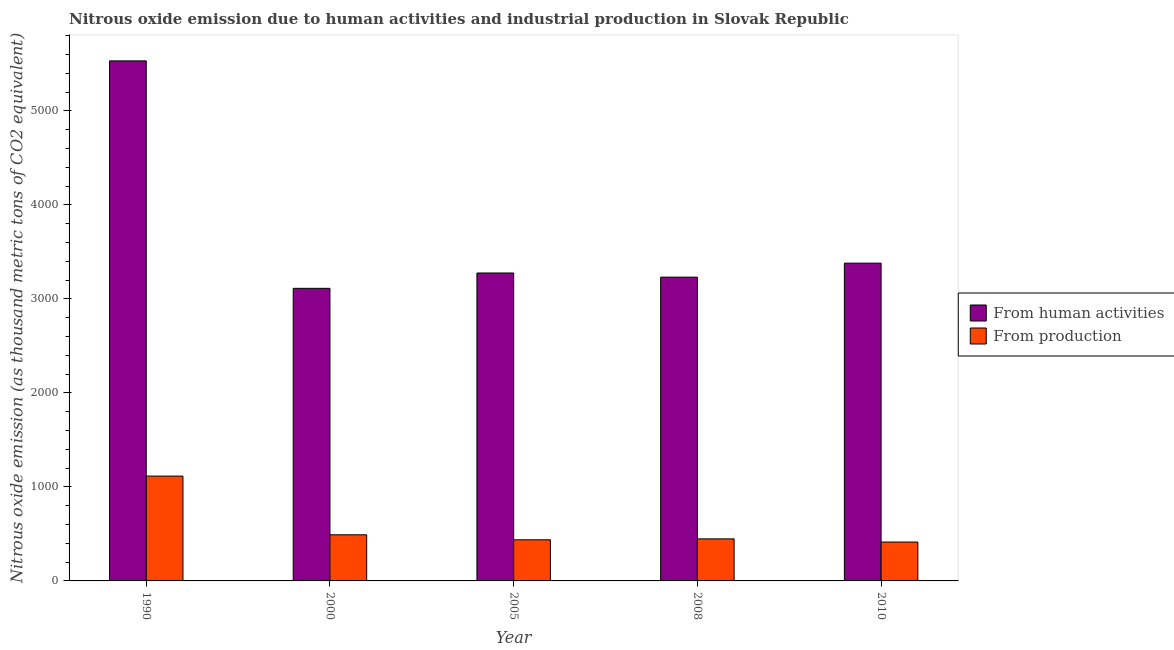How many groups of bars are there?
Your answer should be very brief. 5. Are the number of bars on each tick of the X-axis equal?
Your answer should be compact. Yes. How many bars are there on the 5th tick from the right?
Offer a very short reply. 2. What is the label of the 4th group of bars from the left?
Your response must be concise. 2008. What is the amount of emissions generated from industries in 2005?
Your answer should be very brief. 437.5. Across all years, what is the maximum amount of emissions generated from industries?
Your response must be concise. 1115.2. Across all years, what is the minimum amount of emissions generated from industries?
Keep it short and to the point. 413.6. In which year was the amount of emissions from human activities maximum?
Offer a terse response. 1990. In which year was the amount of emissions generated from industries minimum?
Your answer should be very brief. 2010. What is the total amount of emissions from human activities in the graph?
Offer a terse response. 1.85e+04. What is the difference between the amount of emissions generated from industries in 1990 and that in 2010?
Provide a succinct answer. 701.6. What is the difference between the amount of emissions from human activities in 1990 and the amount of emissions generated from industries in 2005?
Offer a very short reply. 2256.3. What is the average amount of emissions from human activities per year?
Provide a short and direct response. 3706.28. In the year 2008, what is the difference between the amount of emissions generated from industries and amount of emissions from human activities?
Offer a terse response. 0. In how many years, is the amount of emissions generated from industries greater than 2800 thousand metric tons?
Offer a terse response. 0. What is the ratio of the amount of emissions from human activities in 2000 to that in 2005?
Provide a succinct answer. 0.95. What is the difference between the highest and the second highest amount of emissions from human activities?
Keep it short and to the point. 2151.7. What is the difference between the highest and the lowest amount of emissions from human activities?
Your response must be concise. 2419.6. Is the sum of the amount of emissions from human activities in 1990 and 2010 greater than the maximum amount of emissions generated from industries across all years?
Give a very brief answer. Yes. What does the 2nd bar from the left in 2000 represents?
Provide a succinct answer. From production. What does the 2nd bar from the right in 2008 represents?
Offer a terse response. From human activities. How many years are there in the graph?
Your response must be concise. 5. What is the difference between two consecutive major ticks on the Y-axis?
Give a very brief answer. 1000. Does the graph contain any zero values?
Your answer should be very brief. No. Does the graph contain grids?
Offer a very short reply. No. What is the title of the graph?
Offer a very short reply. Nitrous oxide emission due to human activities and industrial production in Slovak Republic. What is the label or title of the X-axis?
Provide a succinct answer. Year. What is the label or title of the Y-axis?
Your response must be concise. Nitrous oxide emission (as thousand metric tons of CO2 equivalent). What is the Nitrous oxide emission (as thousand metric tons of CO2 equivalent) in From human activities in 1990?
Give a very brief answer. 5531.9. What is the Nitrous oxide emission (as thousand metric tons of CO2 equivalent) in From production in 1990?
Provide a succinct answer. 1115.2. What is the Nitrous oxide emission (as thousand metric tons of CO2 equivalent) in From human activities in 2000?
Give a very brief answer. 3112.3. What is the Nitrous oxide emission (as thousand metric tons of CO2 equivalent) in From production in 2000?
Your answer should be very brief. 490.8. What is the Nitrous oxide emission (as thousand metric tons of CO2 equivalent) in From human activities in 2005?
Offer a terse response. 3275.6. What is the Nitrous oxide emission (as thousand metric tons of CO2 equivalent) in From production in 2005?
Keep it short and to the point. 437.5. What is the Nitrous oxide emission (as thousand metric tons of CO2 equivalent) of From human activities in 2008?
Offer a terse response. 3231.4. What is the Nitrous oxide emission (as thousand metric tons of CO2 equivalent) in From production in 2008?
Your answer should be very brief. 447.3. What is the Nitrous oxide emission (as thousand metric tons of CO2 equivalent) of From human activities in 2010?
Your answer should be compact. 3380.2. What is the Nitrous oxide emission (as thousand metric tons of CO2 equivalent) of From production in 2010?
Ensure brevity in your answer.  413.6. Across all years, what is the maximum Nitrous oxide emission (as thousand metric tons of CO2 equivalent) of From human activities?
Provide a short and direct response. 5531.9. Across all years, what is the maximum Nitrous oxide emission (as thousand metric tons of CO2 equivalent) in From production?
Provide a short and direct response. 1115.2. Across all years, what is the minimum Nitrous oxide emission (as thousand metric tons of CO2 equivalent) of From human activities?
Provide a short and direct response. 3112.3. Across all years, what is the minimum Nitrous oxide emission (as thousand metric tons of CO2 equivalent) of From production?
Ensure brevity in your answer.  413.6. What is the total Nitrous oxide emission (as thousand metric tons of CO2 equivalent) in From human activities in the graph?
Provide a succinct answer. 1.85e+04. What is the total Nitrous oxide emission (as thousand metric tons of CO2 equivalent) in From production in the graph?
Your response must be concise. 2904.4. What is the difference between the Nitrous oxide emission (as thousand metric tons of CO2 equivalent) of From human activities in 1990 and that in 2000?
Keep it short and to the point. 2419.6. What is the difference between the Nitrous oxide emission (as thousand metric tons of CO2 equivalent) in From production in 1990 and that in 2000?
Give a very brief answer. 624.4. What is the difference between the Nitrous oxide emission (as thousand metric tons of CO2 equivalent) of From human activities in 1990 and that in 2005?
Provide a succinct answer. 2256.3. What is the difference between the Nitrous oxide emission (as thousand metric tons of CO2 equivalent) in From production in 1990 and that in 2005?
Your answer should be compact. 677.7. What is the difference between the Nitrous oxide emission (as thousand metric tons of CO2 equivalent) in From human activities in 1990 and that in 2008?
Ensure brevity in your answer.  2300.5. What is the difference between the Nitrous oxide emission (as thousand metric tons of CO2 equivalent) of From production in 1990 and that in 2008?
Your answer should be compact. 667.9. What is the difference between the Nitrous oxide emission (as thousand metric tons of CO2 equivalent) in From human activities in 1990 and that in 2010?
Provide a succinct answer. 2151.7. What is the difference between the Nitrous oxide emission (as thousand metric tons of CO2 equivalent) in From production in 1990 and that in 2010?
Your answer should be very brief. 701.6. What is the difference between the Nitrous oxide emission (as thousand metric tons of CO2 equivalent) of From human activities in 2000 and that in 2005?
Provide a short and direct response. -163.3. What is the difference between the Nitrous oxide emission (as thousand metric tons of CO2 equivalent) in From production in 2000 and that in 2005?
Keep it short and to the point. 53.3. What is the difference between the Nitrous oxide emission (as thousand metric tons of CO2 equivalent) in From human activities in 2000 and that in 2008?
Offer a very short reply. -119.1. What is the difference between the Nitrous oxide emission (as thousand metric tons of CO2 equivalent) in From production in 2000 and that in 2008?
Give a very brief answer. 43.5. What is the difference between the Nitrous oxide emission (as thousand metric tons of CO2 equivalent) of From human activities in 2000 and that in 2010?
Provide a succinct answer. -267.9. What is the difference between the Nitrous oxide emission (as thousand metric tons of CO2 equivalent) in From production in 2000 and that in 2010?
Your answer should be compact. 77.2. What is the difference between the Nitrous oxide emission (as thousand metric tons of CO2 equivalent) in From human activities in 2005 and that in 2008?
Offer a very short reply. 44.2. What is the difference between the Nitrous oxide emission (as thousand metric tons of CO2 equivalent) of From human activities in 2005 and that in 2010?
Make the answer very short. -104.6. What is the difference between the Nitrous oxide emission (as thousand metric tons of CO2 equivalent) of From production in 2005 and that in 2010?
Your answer should be compact. 23.9. What is the difference between the Nitrous oxide emission (as thousand metric tons of CO2 equivalent) in From human activities in 2008 and that in 2010?
Provide a short and direct response. -148.8. What is the difference between the Nitrous oxide emission (as thousand metric tons of CO2 equivalent) of From production in 2008 and that in 2010?
Ensure brevity in your answer.  33.7. What is the difference between the Nitrous oxide emission (as thousand metric tons of CO2 equivalent) of From human activities in 1990 and the Nitrous oxide emission (as thousand metric tons of CO2 equivalent) of From production in 2000?
Your response must be concise. 5041.1. What is the difference between the Nitrous oxide emission (as thousand metric tons of CO2 equivalent) of From human activities in 1990 and the Nitrous oxide emission (as thousand metric tons of CO2 equivalent) of From production in 2005?
Your answer should be very brief. 5094.4. What is the difference between the Nitrous oxide emission (as thousand metric tons of CO2 equivalent) in From human activities in 1990 and the Nitrous oxide emission (as thousand metric tons of CO2 equivalent) in From production in 2008?
Your answer should be very brief. 5084.6. What is the difference between the Nitrous oxide emission (as thousand metric tons of CO2 equivalent) of From human activities in 1990 and the Nitrous oxide emission (as thousand metric tons of CO2 equivalent) of From production in 2010?
Provide a short and direct response. 5118.3. What is the difference between the Nitrous oxide emission (as thousand metric tons of CO2 equivalent) of From human activities in 2000 and the Nitrous oxide emission (as thousand metric tons of CO2 equivalent) of From production in 2005?
Offer a terse response. 2674.8. What is the difference between the Nitrous oxide emission (as thousand metric tons of CO2 equivalent) in From human activities in 2000 and the Nitrous oxide emission (as thousand metric tons of CO2 equivalent) in From production in 2008?
Your response must be concise. 2665. What is the difference between the Nitrous oxide emission (as thousand metric tons of CO2 equivalent) of From human activities in 2000 and the Nitrous oxide emission (as thousand metric tons of CO2 equivalent) of From production in 2010?
Give a very brief answer. 2698.7. What is the difference between the Nitrous oxide emission (as thousand metric tons of CO2 equivalent) in From human activities in 2005 and the Nitrous oxide emission (as thousand metric tons of CO2 equivalent) in From production in 2008?
Offer a terse response. 2828.3. What is the difference between the Nitrous oxide emission (as thousand metric tons of CO2 equivalent) of From human activities in 2005 and the Nitrous oxide emission (as thousand metric tons of CO2 equivalent) of From production in 2010?
Your answer should be very brief. 2862. What is the difference between the Nitrous oxide emission (as thousand metric tons of CO2 equivalent) in From human activities in 2008 and the Nitrous oxide emission (as thousand metric tons of CO2 equivalent) in From production in 2010?
Ensure brevity in your answer.  2817.8. What is the average Nitrous oxide emission (as thousand metric tons of CO2 equivalent) in From human activities per year?
Your answer should be compact. 3706.28. What is the average Nitrous oxide emission (as thousand metric tons of CO2 equivalent) in From production per year?
Make the answer very short. 580.88. In the year 1990, what is the difference between the Nitrous oxide emission (as thousand metric tons of CO2 equivalent) of From human activities and Nitrous oxide emission (as thousand metric tons of CO2 equivalent) of From production?
Make the answer very short. 4416.7. In the year 2000, what is the difference between the Nitrous oxide emission (as thousand metric tons of CO2 equivalent) of From human activities and Nitrous oxide emission (as thousand metric tons of CO2 equivalent) of From production?
Make the answer very short. 2621.5. In the year 2005, what is the difference between the Nitrous oxide emission (as thousand metric tons of CO2 equivalent) in From human activities and Nitrous oxide emission (as thousand metric tons of CO2 equivalent) in From production?
Make the answer very short. 2838.1. In the year 2008, what is the difference between the Nitrous oxide emission (as thousand metric tons of CO2 equivalent) in From human activities and Nitrous oxide emission (as thousand metric tons of CO2 equivalent) in From production?
Provide a short and direct response. 2784.1. In the year 2010, what is the difference between the Nitrous oxide emission (as thousand metric tons of CO2 equivalent) of From human activities and Nitrous oxide emission (as thousand metric tons of CO2 equivalent) of From production?
Keep it short and to the point. 2966.6. What is the ratio of the Nitrous oxide emission (as thousand metric tons of CO2 equivalent) of From human activities in 1990 to that in 2000?
Give a very brief answer. 1.78. What is the ratio of the Nitrous oxide emission (as thousand metric tons of CO2 equivalent) in From production in 1990 to that in 2000?
Offer a very short reply. 2.27. What is the ratio of the Nitrous oxide emission (as thousand metric tons of CO2 equivalent) of From human activities in 1990 to that in 2005?
Provide a short and direct response. 1.69. What is the ratio of the Nitrous oxide emission (as thousand metric tons of CO2 equivalent) in From production in 1990 to that in 2005?
Give a very brief answer. 2.55. What is the ratio of the Nitrous oxide emission (as thousand metric tons of CO2 equivalent) of From human activities in 1990 to that in 2008?
Your answer should be compact. 1.71. What is the ratio of the Nitrous oxide emission (as thousand metric tons of CO2 equivalent) in From production in 1990 to that in 2008?
Offer a very short reply. 2.49. What is the ratio of the Nitrous oxide emission (as thousand metric tons of CO2 equivalent) in From human activities in 1990 to that in 2010?
Offer a very short reply. 1.64. What is the ratio of the Nitrous oxide emission (as thousand metric tons of CO2 equivalent) in From production in 1990 to that in 2010?
Offer a terse response. 2.7. What is the ratio of the Nitrous oxide emission (as thousand metric tons of CO2 equivalent) of From human activities in 2000 to that in 2005?
Offer a very short reply. 0.95. What is the ratio of the Nitrous oxide emission (as thousand metric tons of CO2 equivalent) of From production in 2000 to that in 2005?
Provide a short and direct response. 1.12. What is the ratio of the Nitrous oxide emission (as thousand metric tons of CO2 equivalent) of From human activities in 2000 to that in 2008?
Offer a very short reply. 0.96. What is the ratio of the Nitrous oxide emission (as thousand metric tons of CO2 equivalent) of From production in 2000 to that in 2008?
Offer a terse response. 1.1. What is the ratio of the Nitrous oxide emission (as thousand metric tons of CO2 equivalent) of From human activities in 2000 to that in 2010?
Your response must be concise. 0.92. What is the ratio of the Nitrous oxide emission (as thousand metric tons of CO2 equivalent) in From production in 2000 to that in 2010?
Offer a very short reply. 1.19. What is the ratio of the Nitrous oxide emission (as thousand metric tons of CO2 equivalent) of From human activities in 2005 to that in 2008?
Ensure brevity in your answer.  1.01. What is the ratio of the Nitrous oxide emission (as thousand metric tons of CO2 equivalent) of From production in 2005 to that in 2008?
Your answer should be compact. 0.98. What is the ratio of the Nitrous oxide emission (as thousand metric tons of CO2 equivalent) in From human activities in 2005 to that in 2010?
Keep it short and to the point. 0.97. What is the ratio of the Nitrous oxide emission (as thousand metric tons of CO2 equivalent) of From production in 2005 to that in 2010?
Your answer should be very brief. 1.06. What is the ratio of the Nitrous oxide emission (as thousand metric tons of CO2 equivalent) of From human activities in 2008 to that in 2010?
Provide a short and direct response. 0.96. What is the ratio of the Nitrous oxide emission (as thousand metric tons of CO2 equivalent) in From production in 2008 to that in 2010?
Provide a short and direct response. 1.08. What is the difference between the highest and the second highest Nitrous oxide emission (as thousand metric tons of CO2 equivalent) of From human activities?
Offer a terse response. 2151.7. What is the difference between the highest and the second highest Nitrous oxide emission (as thousand metric tons of CO2 equivalent) in From production?
Provide a short and direct response. 624.4. What is the difference between the highest and the lowest Nitrous oxide emission (as thousand metric tons of CO2 equivalent) of From human activities?
Your answer should be very brief. 2419.6. What is the difference between the highest and the lowest Nitrous oxide emission (as thousand metric tons of CO2 equivalent) in From production?
Provide a succinct answer. 701.6. 